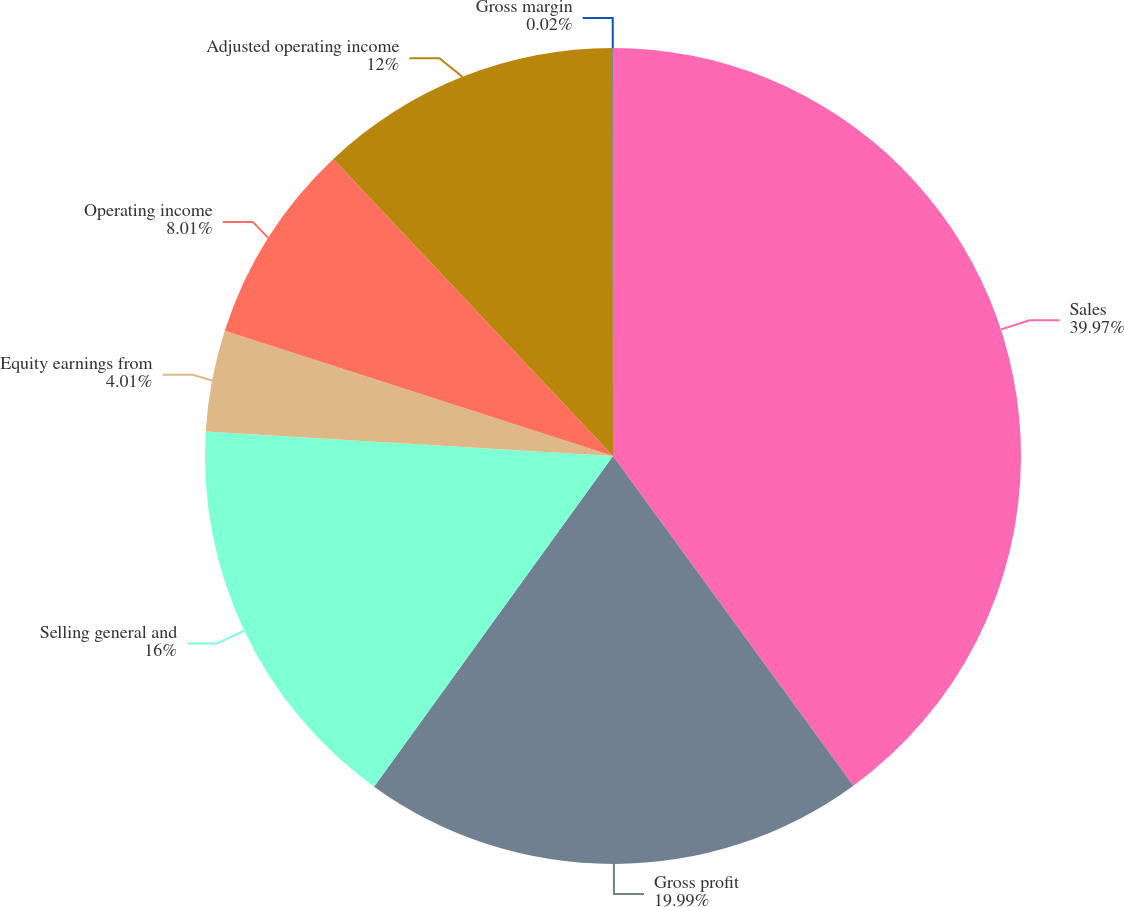<chart> <loc_0><loc_0><loc_500><loc_500><pie_chart><fcel>Sales<fcel>Gross profit<fcel>Selling general and<fcel>Equity earnings from<fcel>Operating income<fcel>Adjusted operating income<fcel>Gross margin<nl><fcel>39.97%<fcel>19.99%<fcel>16.0%<fcel>4.01%<fcel>8.01%<fcel>12.0%<fcel>0.02%<nl></chart> 